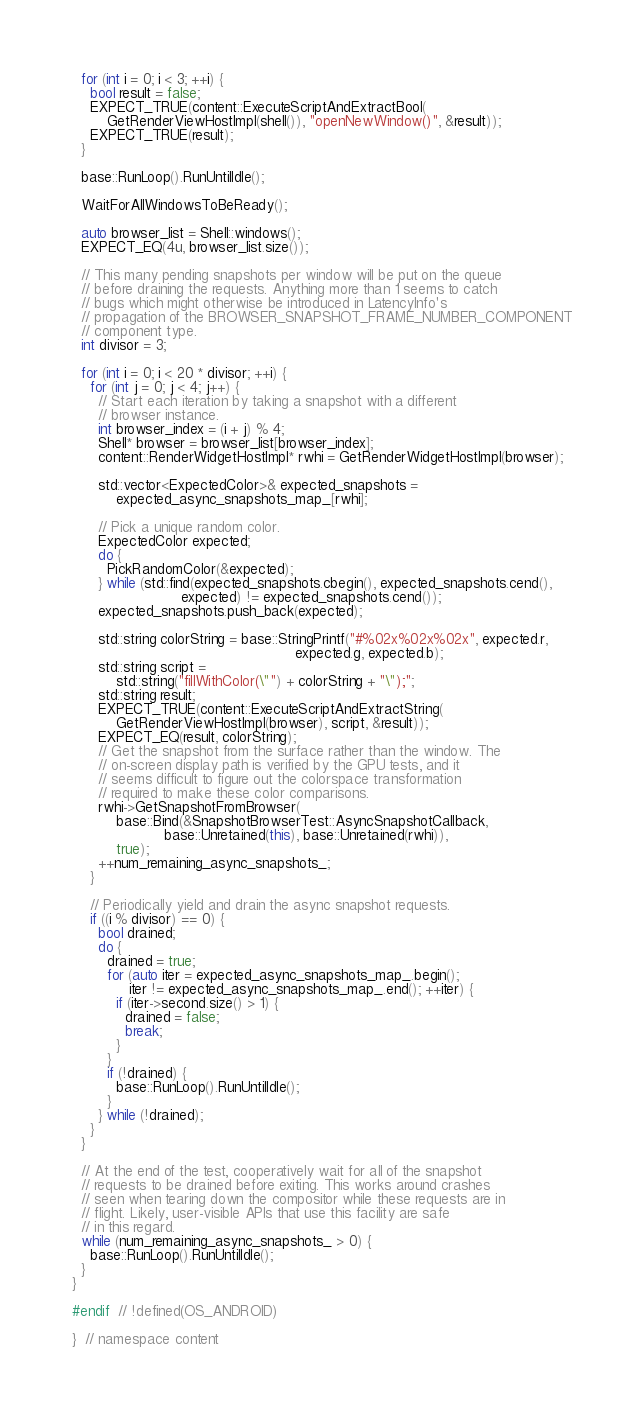Convert code to text. <code><loc_0><loc_0><loc_500><loc_500><_C++_>
  for (int i = 0; i < 3; ++i) {
    bool result = false;
    EXPECT_TRUE(content::ExecuteScriptAndExtractBool(
        GetRenderViewHostImpl(shell()), "openNewWindow()", &result));
    EXPECT_TRUE(result);
  }

  base::RunLoop().RunUntilIdle();

  WaitForAllWindowsToBeReady();

  auto browser_list = Shell::windows();
  EXPECT_EQ(4u, browser_list.size());

  // This many pending snapshots per window will be put on the queue
  // before draining the requests. Anything more than 1 seems to catch
  // bugs which might otherwise be introduced in LatencyInfo's
  // propagation of the BROWSER_SNAPSHOT_FRAME_NUMBER_COMPONENT
  // component type.
  int divisor = 3;

  for (int i = 0; i < 20 * divisor; ++i) {
    for (int j = 0; j < 4; j++) {
      // Start each iteration by taking a snapshot with a different
      // browser instance.
      int browser_index = (i + j) % 4;
      Shell* browser = browser_list[browser_index];
      content::RenderWidgetHostImpl* rwhi = GetRenderWidgetHostImpl(browser);

      std::vector<ExpectedColor>& expected_snapshots =
          expected_async_snapshots_map_[rwhi];

      // Pick a unique random color.
      ExpectedColor expected;
      do {
        PickRandomColor(&expected);
      } while (std::find(expected_snapshots.cbegin(), expected_snapshots.cend(),
                         expected) != expected_snapshots.cend());
      expected_snapshots.push_back(expected);

      std::string colorString = base::StringPrintf("#%02x%02x%02x", expected.r,
                                                   expected.g, expected.b);
      std::string script =
          std::string("fillWithColor(\"") + colorString + "\");";
      std::string result;
      EXPECT_TRUE(content::ExecuteScriptAndExtractString(
          GetRenderViewHostImpl(browser), script, &result));
      EXPECT_EQ(result, colorString);
      // Get the snapshot from the surface rather than the window. The
      // on-screen display path is verified by the GPU tests, and it
      // seems difficult to figure out the colorspace transformation
      // required to make these color comparisons.
      rwhi->GetSnapshotFromBrowser(
          base::Bind(&SnapshotBrowserTest::AsyncSnapshotCallback,
                     base::Unretained(this), base::Unretained(rwhi)),
          true);
      ++num_remaining_async_snapshots_;
    }

    // Periodically yield and drain the async snapshot requests.
    if ((i % divisor) == 0) {
      bool drained;
      do {
        drained = true;
        for (auto iter = expected_async_snapshots_map_.begin();
             iter != expected_async_snapshots_map_.end(); ++iter) {
          if (iter->second.size() > 1) {
            drained = false;
            break;
          }
        }
        if (!drained) {
          base::RunLoop().RunUntilIdle();
        }
      } while (!drained);
    }
  }

  // At the end of the test, cooperatively wait for all of the snapshot
  // requests to be drained before exiting. This works around crashes
  // seen when tearing down the compositor while these requests are in
  // flight. Likely, user-visible APIs that use this facility are safe
  // in this regard.
  while (num_remaining_async_snapshots_ > 0) {
    base::RunLoop().RunUntilIdle();
  }
}

#endif  // !defined(OS_ANDROID)

}  // namespace content
</code> 